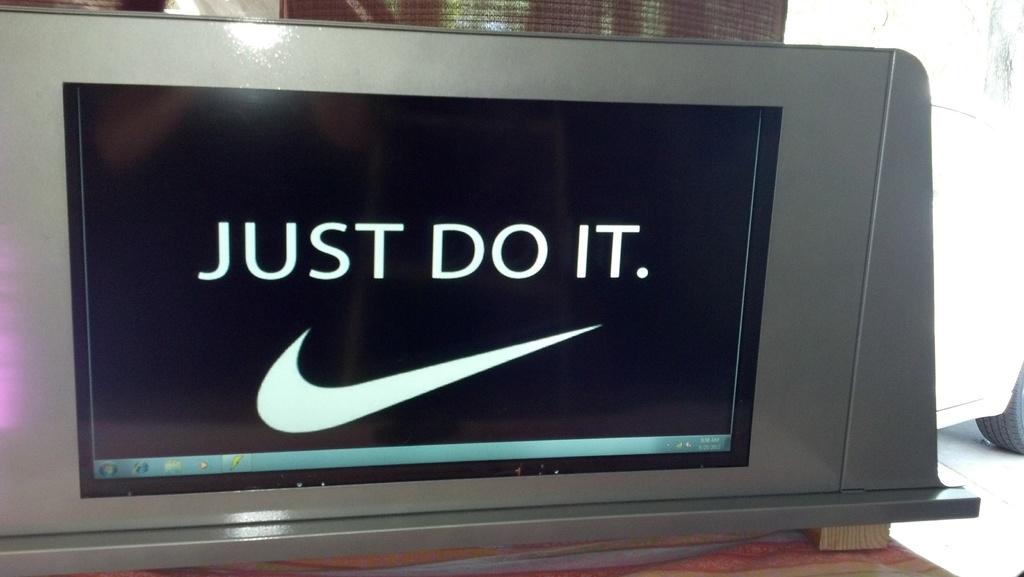What is the tag line above the logo?
Your answer should be very brief. Just do it. What does the nike logo say above it?
Provide a short and direct response. Just do it. 